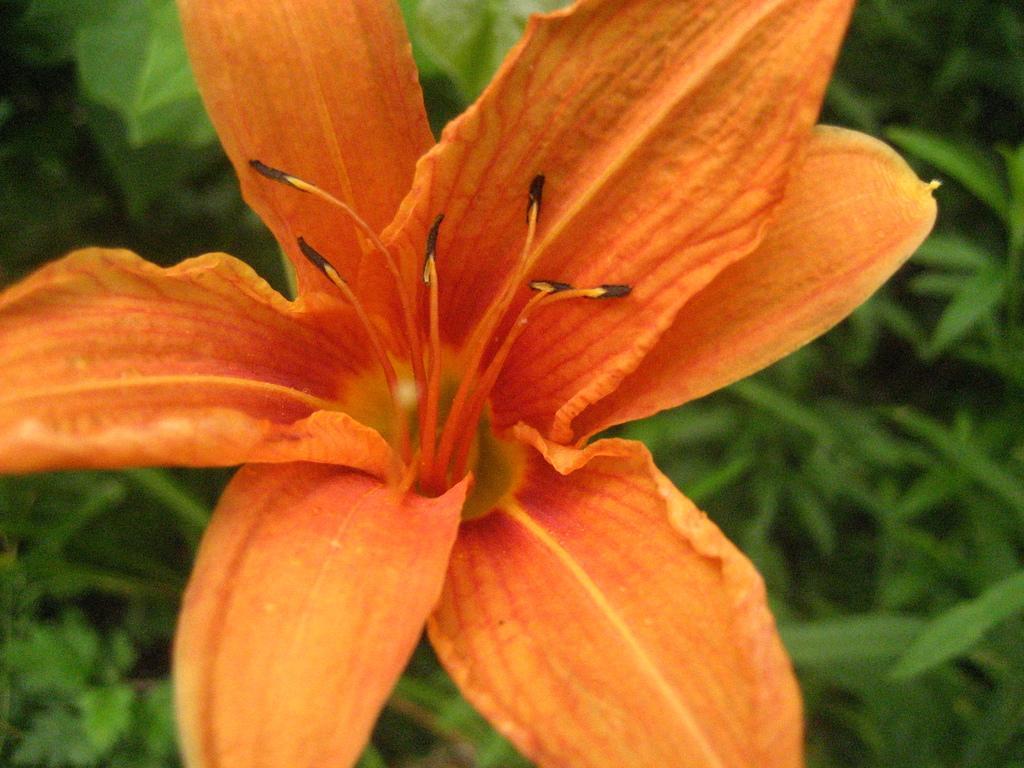Can you describe this image briefly? In the center of the image we can see flower and plants. 